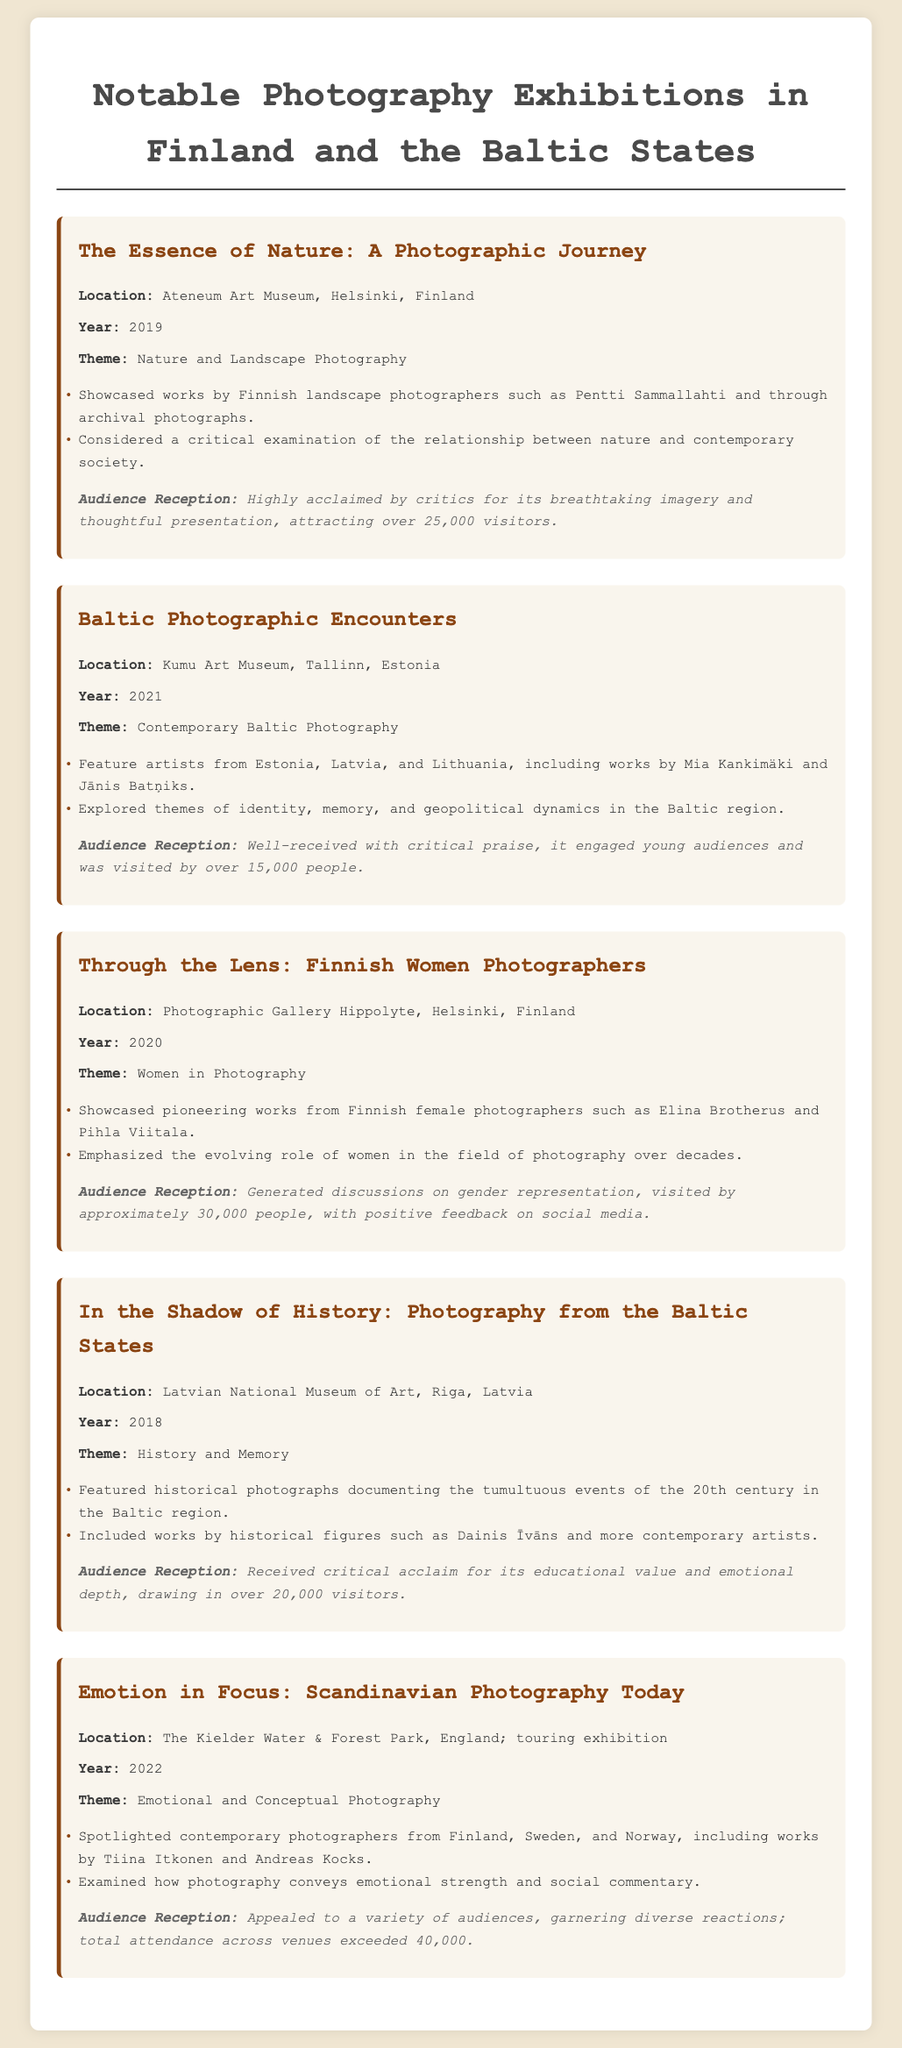What was the theme of the exhibition "In the Shadow of History"? The theme is detailed in the document as "History and Memory."
Answer: History and Memory How many visitors attended the exhibition "Through the Lens: Finnish Women Photographers"? The document states that it was visited by approximately 30,000 people.
Answer: 30,000 Who were featured artists in the "Baltic Photographic Encounters"? The document lists Mia Kankimäki and Jānis Batņiks as featured artists.
Answer: Mia Kankimäki and Jānis Batņiks In which year was "The Essence of Nature: A Photographic Journey" held? The document specifies that the exhibition took place in 2019.
Answer: 2019 Which venue hosted the "Emotion in Focus: Scandinavian Photography Today"? According to the document, it was hosted at The Kielder Water & Forest Park.
Answer: The Kielder Water & Forest Park What major theme is associated with the exhibition "Through the Lens: Finnish Women Photographers"? The document describes the theme as "Women in Photography."
Answer: Women in Photography How many exhibitions are highlighted in the document? The document lists a total of five significant photography exhibitions.
Answer: Five Which exhibition had a critical acclaim with emphasis on gender representation? The document indicates that "Through the Lens: Finnish Women Photographers" had this focus.
Answer: Through the Lens: Finnish Women Photographers 